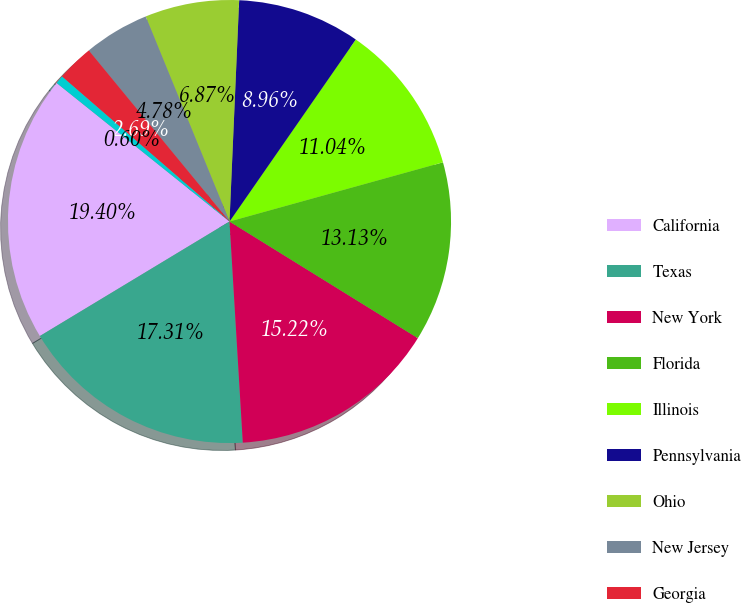Convert chart. <chart><loc_0><loc_0><loc_500><loc_500><pie_chart><fcel>California<fcel>Texas<fcel>New York<fcel>Florida<fcel>Illinois<fcel>Pennsylvania<fcel>Ohio<fcel>New Jersey<fcel>Georgia<fcel>Michigan<nl><fcel>19.4%<fcel>17.31%<fcel>15.22%<fcel>13.13%<fcel>11.04%<fcel>8.96%<fcel>6.87%<fcel>4.78%<fcel>2.69%<fcel>0.6%<nl></chart> 